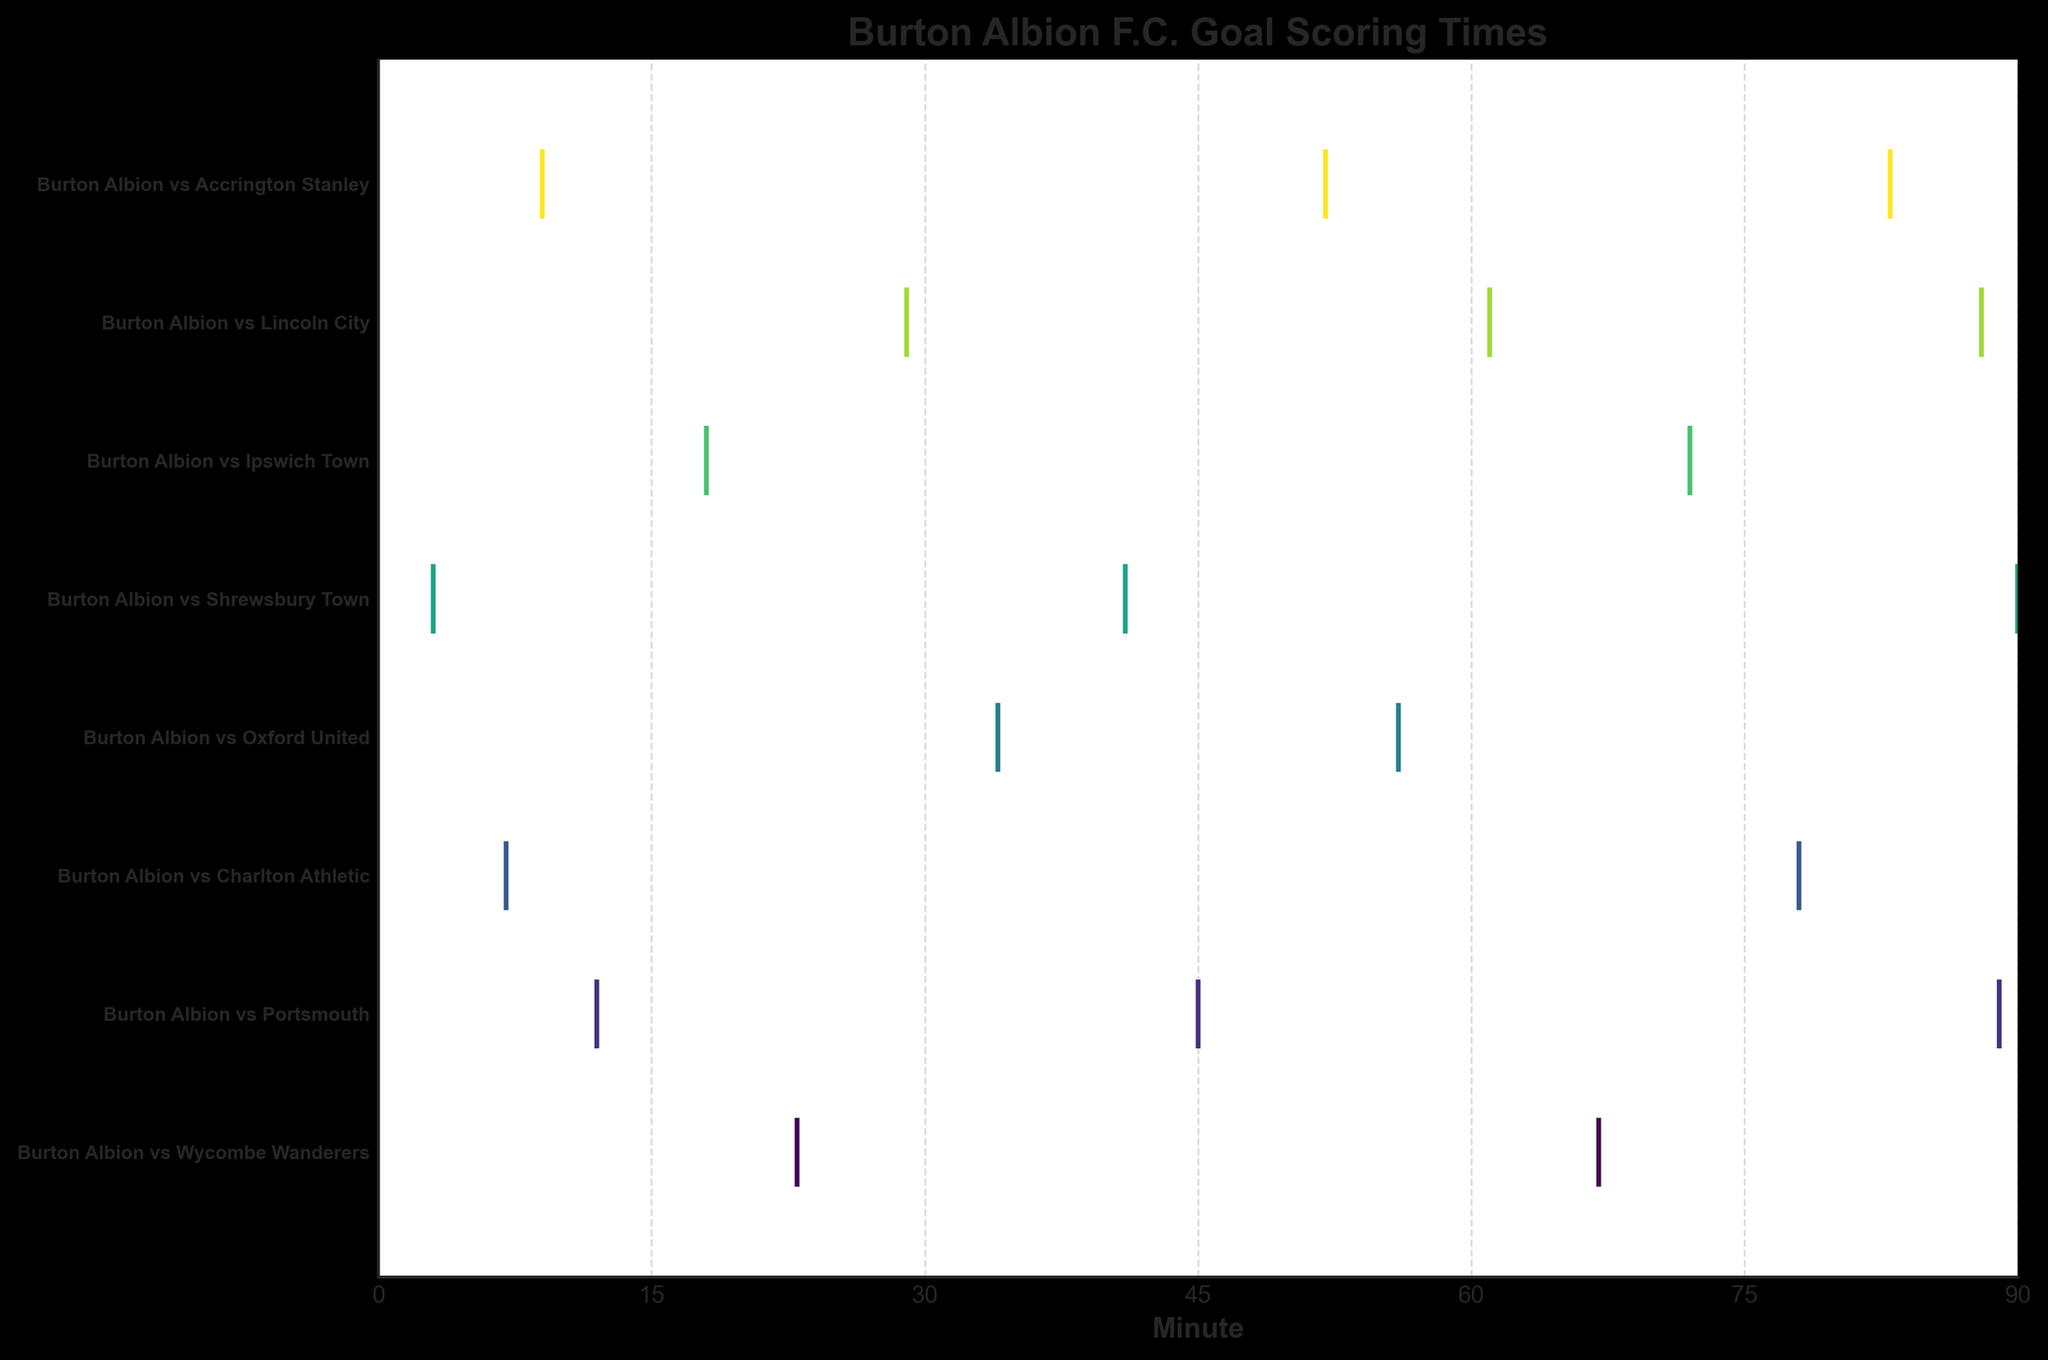Which match had the earliest goal? Identify the data point closest to the left (earliest minute) for each match. The earliest goal is at 3 minutes in the Burton Albion vs Shrewsbury Town match.
Answer: Burton Albion vs Shrewsbury Town How many goals were scored by Burton Albion F.C in the match against Portsmouth? Count the number of event markers for Burton Albion vs Portsmouth. There are 3 markers.
Answer: 3 What is the range of minutes in which goals were scored against Wycombe Wanderers? Look at the event markers for Wycombe Wanderers and note the earliest and latest minute values. The goals were scored at 23 and 67 minutes.
Answer: 23 to 67 Which match had the most goals scored? Compare the number of event markers for each match. The match against Shrewsbury Town has 3 markers, which is the highest.
Answer: Burton Albion vs Portsmouth During which match did Burton Albion score a goal at the 90th minute? Look for the data point at the 90th minute and identify which match it corresponds to. It corresponds to the match against Shrewsbury Town.
Answer: Burton Albion vs Shrewsbury Town How many goals did Burton Albion score in the first half (0-45 minutes) against Lincoln City? Count the event markers for Burton Albion vs Lincoln City within the 0-45 minute range. There is 1 marker at 29 minutes.
Answer: 1 Which match had the most spread out goal times (earliest vs latest goal)? Determine the spread by subtracting the minute of the earliest goal from the latest goal for each match. Match against Portsmouth has goals at 12 and 89 minutes, giving a spread of 77 minutes, which is the largest.
Answer: Burton Albion vs Portsmouth How many matches had goals scored in the second half (45-90 minutes)? Count the matches that have at least one event marker in the 45-90 minute range. There are 6 matches (Wycombe Wanderers, Charlton Athletic, Oxford United, Lincoln City, Ipswich Town, Accrington Stanley).
Answer: 6 In which match did Burton Albion score goals at the 18th and 72nd minutes? Identify the match(s) with event markers at 18 and 72 minutes on the horizontal plot. It corresponds to the match against Ipswich Town.
Answer: Burton Albion vs Ipswich Town 